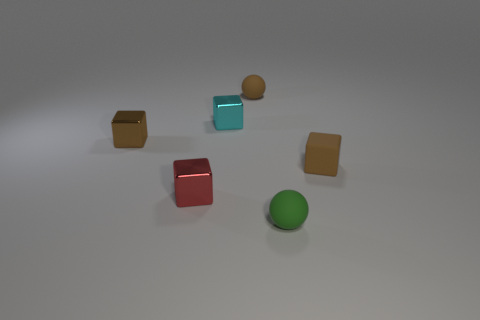Is there another block made of the same material as the small red block?
Offer a terse response. Yes. What number of tiny brown cubes are both to the right of the red shiny block and to the left of the cyan shiny cube?
Keep it short and to the point. 0. Are there fewer small red blocks that are on the right side of the small brown rubber sphere than tiny shiny things that are behind the small red block?
Give a very brief answer. Yes. Is the cyan object the same shape as the tiny brown metallic object?
Provide a succinct answer. Yes. How many other objects are the same size as the red thing?
Provide a short and direct response. 5. How many things are small brown rubber objects left of the tiny green matte ball or objects on the right side of the small cyan metal cube?
Offer a terse response. 3. What number of other metal objects have the same shape as the red metallic object?
Provide a short and direct response. 2. There is a small brown thing that is right of the red object and behind the brown rubber cube; what is it made of?
Give a very brief answer. Rubber. How many tiny blocks are behind the brown sphere?
Offer a very short reply. 0. How many red metal cubes are there?
Your answer should be very brief. 1. 